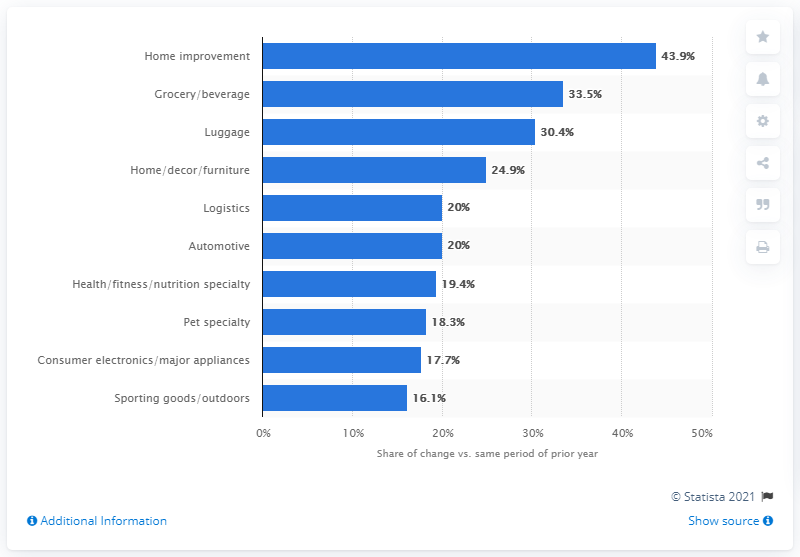List a handful of essential elements in this visual. The growth rate of the consumer electronics and major appliances category was 17.7%. 